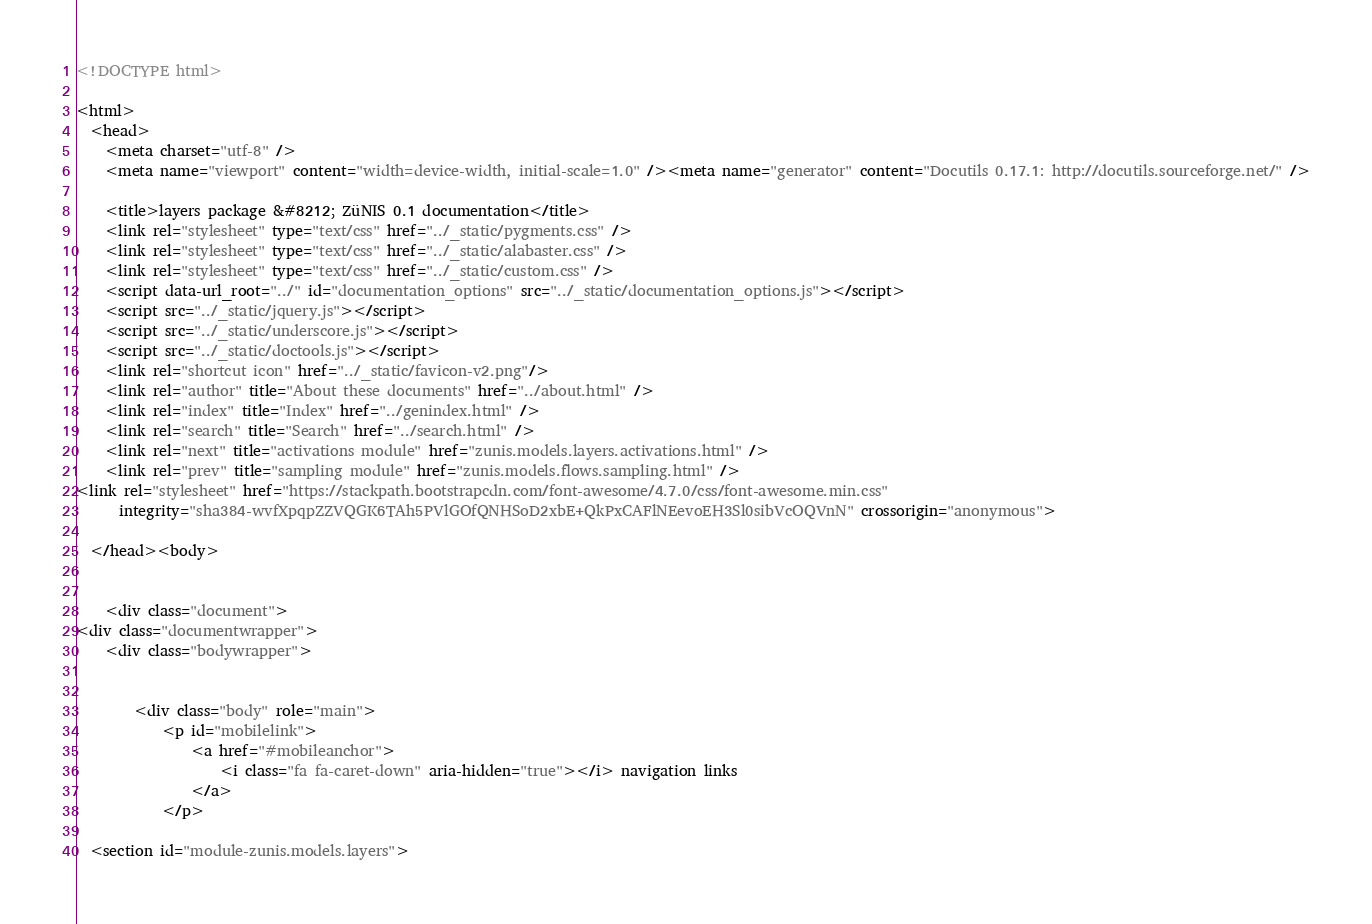Convert code to text. <code><loc_0><loc_0><loc_500><loc_500><_HTML_>
<!DOCTYPE html>

<html>
  <head>
    <meta charset="utf-8" />
    <meta name="viewport" content="width=device-width, initial-scale=1.0" /><meta name="generator" content="Docutils 0.17.1: http://docutils.sourceforge.net/" />

    <title>layers package &#8212; ZüNIS 0.1 documentation</title>
    <link rel="stylesheet" type="text/css" href="../_static/pygments.css" />
    <link rel="stylesheet" type="text/css" href="../_static/alabaster.css" />
    <link rel="stylesheet" type="text/css" href="../_static/custom.css" />
    <script data-url_root="../" id="documentation_options" src="../_static/documentation_options.js"></script>
    <script src="../_static/jquery.js"></script>
    <script src="../_static/underscore.js"></script>
    <script src="../_static/doctools.js"></script>
    <link rel="shortcut icon" href="../_static/favicon-v2.png"/>
    <link rel="author" title="About these documents" href="../about.html" />
    <link rel="index" title="Index" href="../genindex.html" />
    <link rel="search" title="Search" href="../search.html" />
    <link rel="next" title="activations module" href="zunis.models.layers.activations.html" />
    <link rel="prev" title="sampling module" href="zunis.models.flows.sampling.html" />
<link rel="stylesheet" href="https://stackpath.bootstrapcdn.com/font-awesome/4.7.0/css/font-awesome.min.css"
      integrity="sha384-wvfXpqpZZVQGK6TAh5PVlGOfQNHSoD2xbE+QkPxCAFlNEevoEH3Sl0sibVcOQVnN" crossorigin="anonymous">

  </head><body>
  

    <div class="document">
<div class="documentwrapper">
    <div class="bodywrapper">
        

        <div class="body" role="main">
            <p id="mobilelink">
                <a href="#mobileanchor">
                    <i class="fa fa-caret-down" aria-hidden="true"></i> navigation links
                </a>
            </p>
            
  <section id="module-zunis.models.layers"></code> 